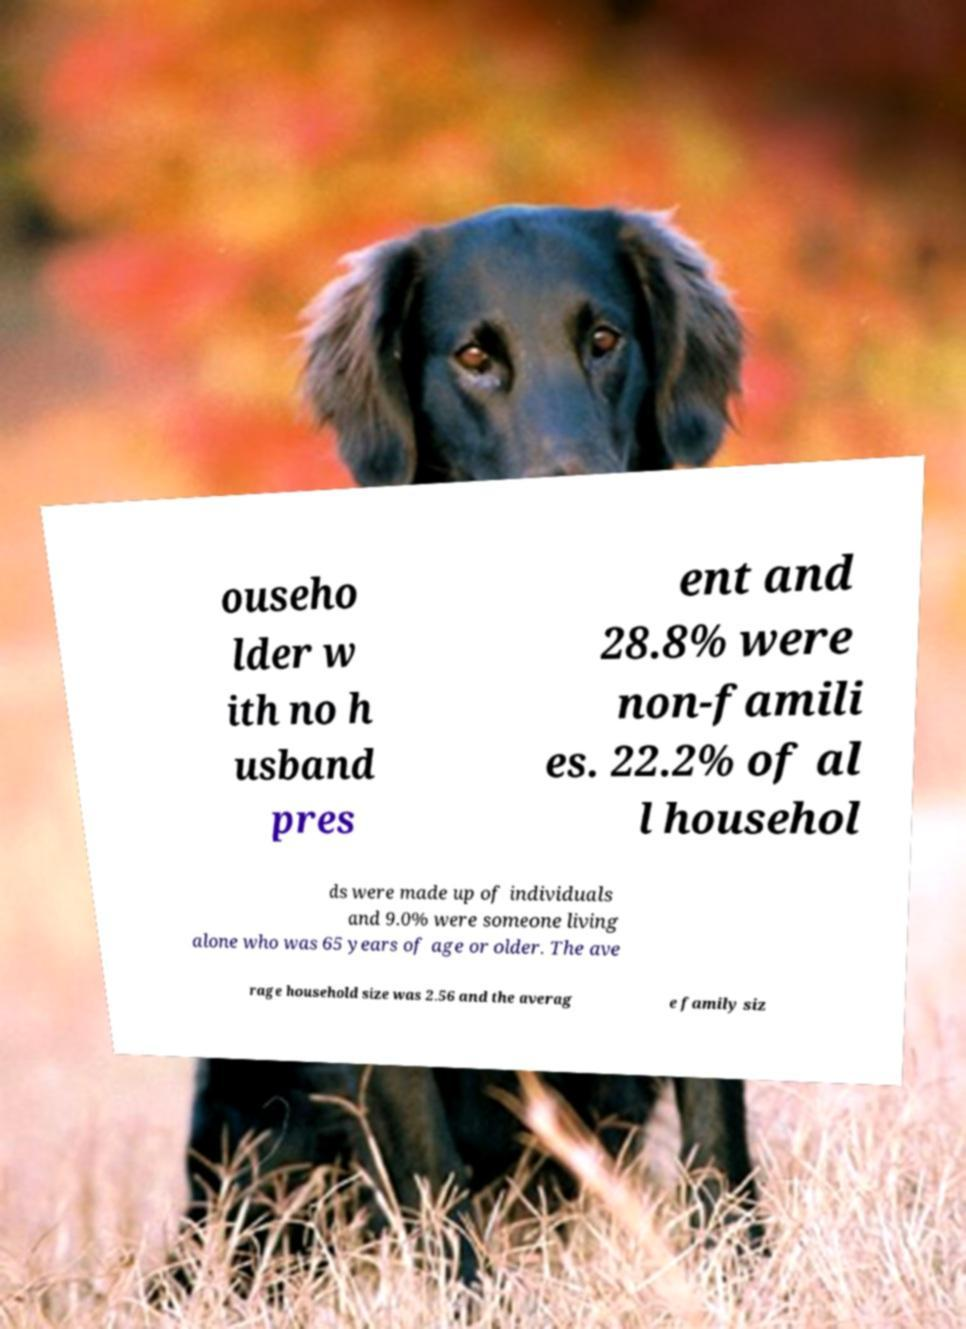For documentation purposes, I need the text within this image transcribed. Could you provide that? ouseho lder w ith no h usband pres ent and 28.8% were non-famili es. 22.2% of al l househol ds were made up of individuals and 9.0% were someone living alone who was 65 years of age or older. The ave rage household size was 2.56 and the averag e family siz 